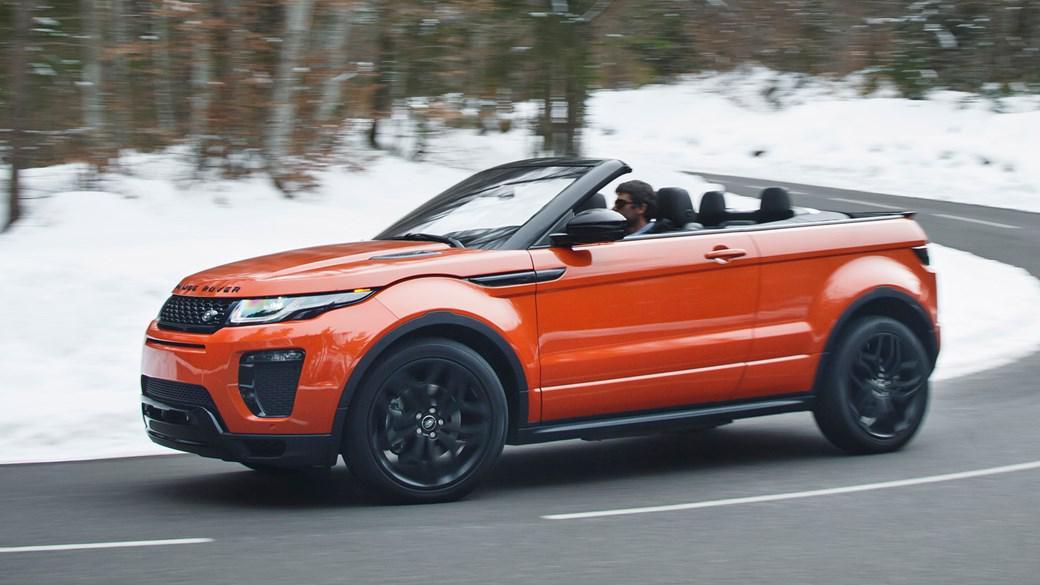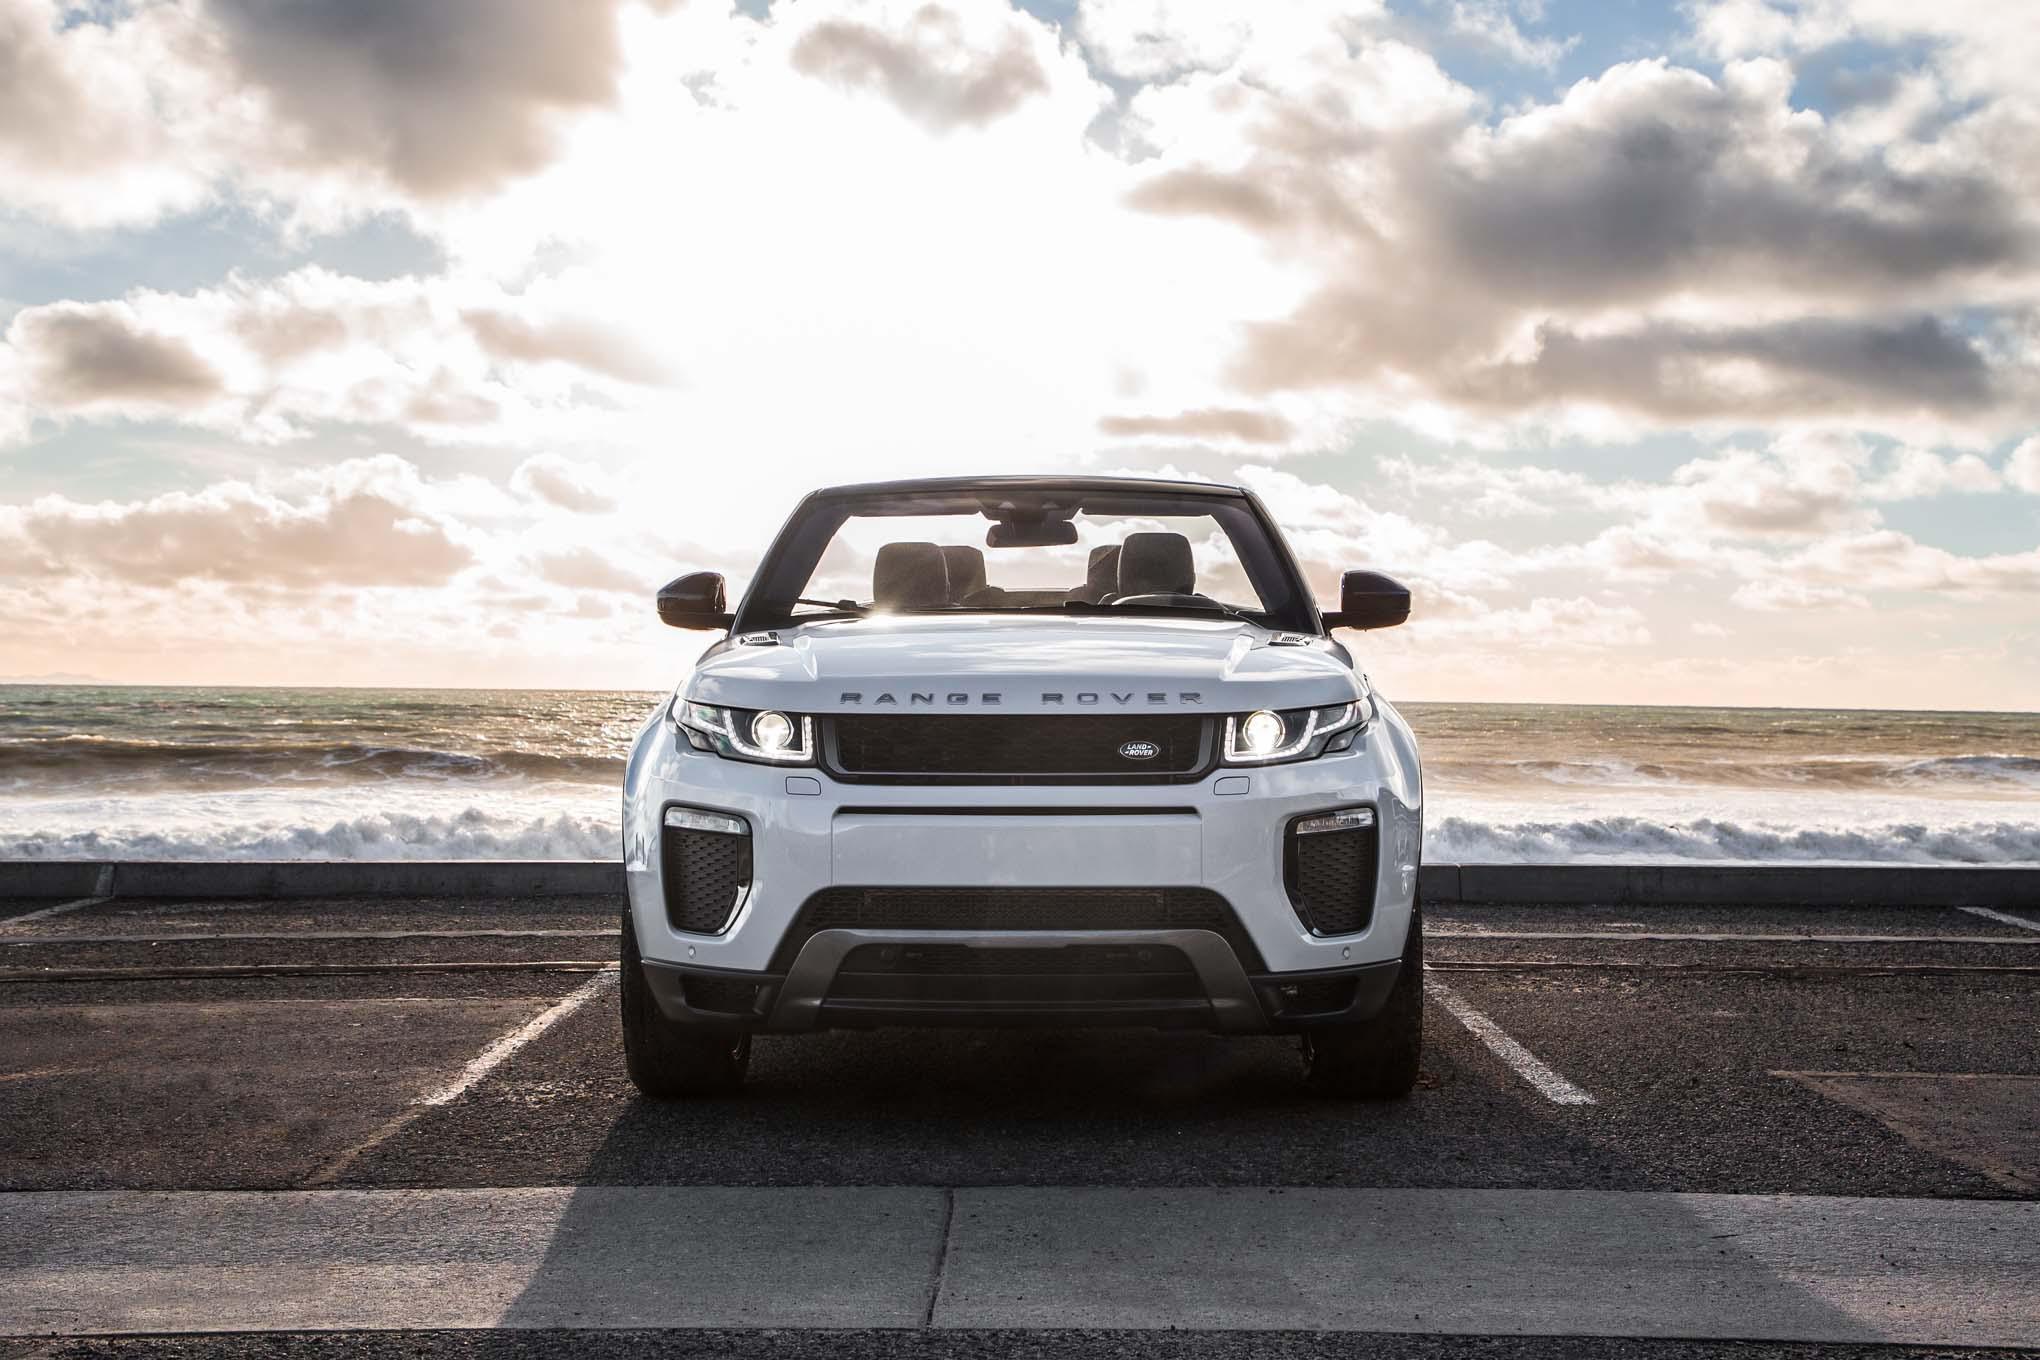The first image is the image on the left, the second image is the image on the right. Considering the images on both sides, is "The car in one of the images is driving near a snowy location." valid? Answer yes or no. Yes. The first image is the image on the left, the second image is the image on the right. Examine the images to the left and right. Is the description "All cars are topless convertibles, and one car is bright orange while the other is white." accurate? Answer yes or no. Yes. 